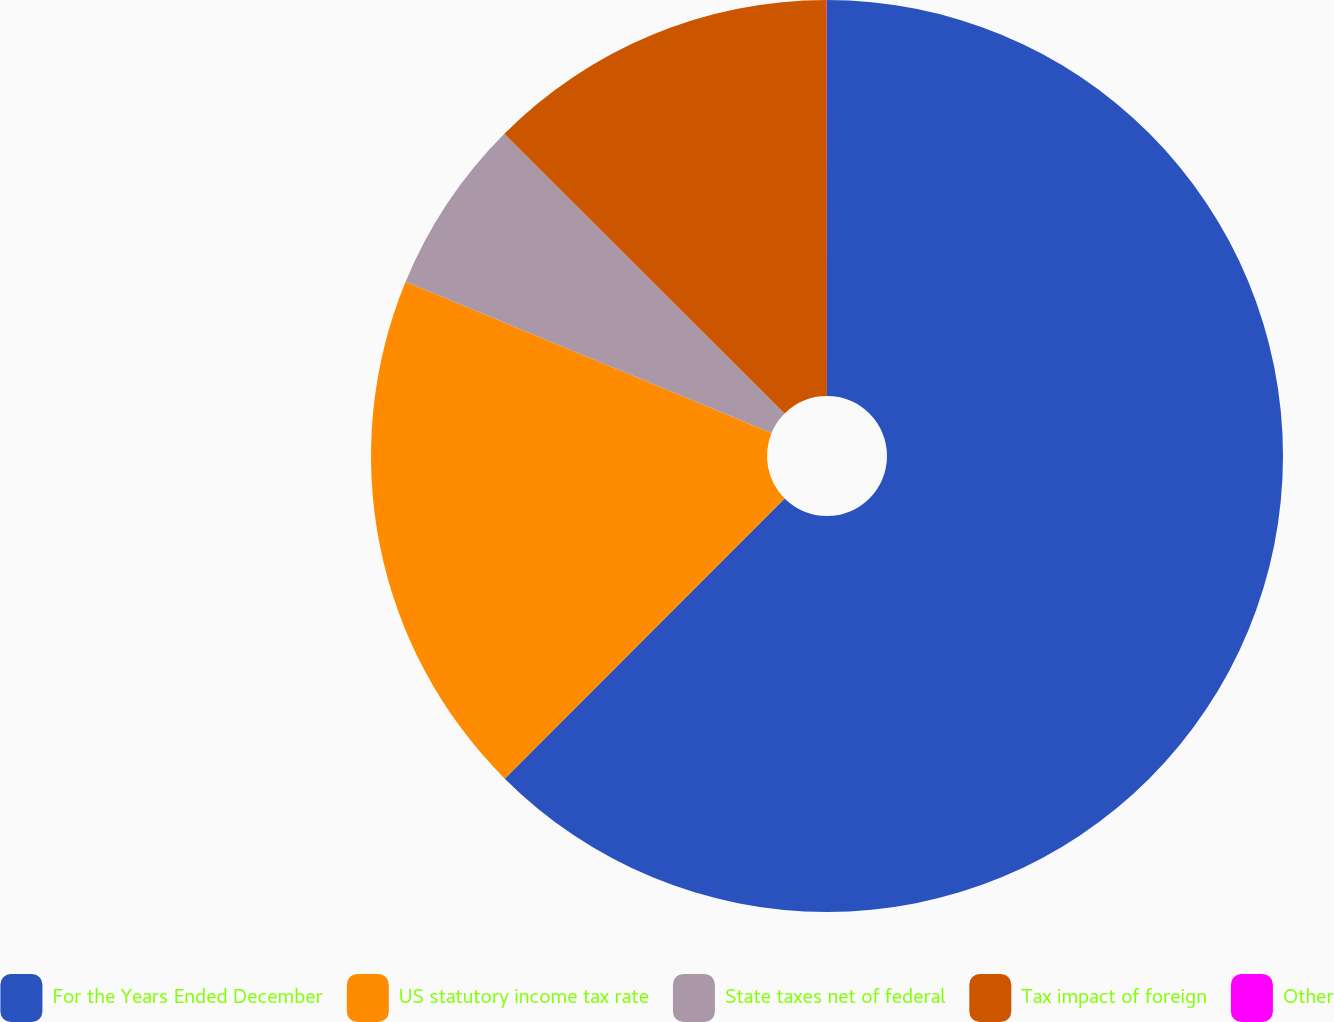<chart> <loc_0><loc_0><loc_500><loc_500><pie_chart><fcel>For the Years Ended December<fcel>US statutory income tax rate<fcel>State taxes net of federal<fcel>Tax impact of foreign<fcel>Other<nl><fcel>62.49%<fcel>18.75%<fcel>6.25%<fcel>12.5%<fcel>0.01%<nl></chart> 